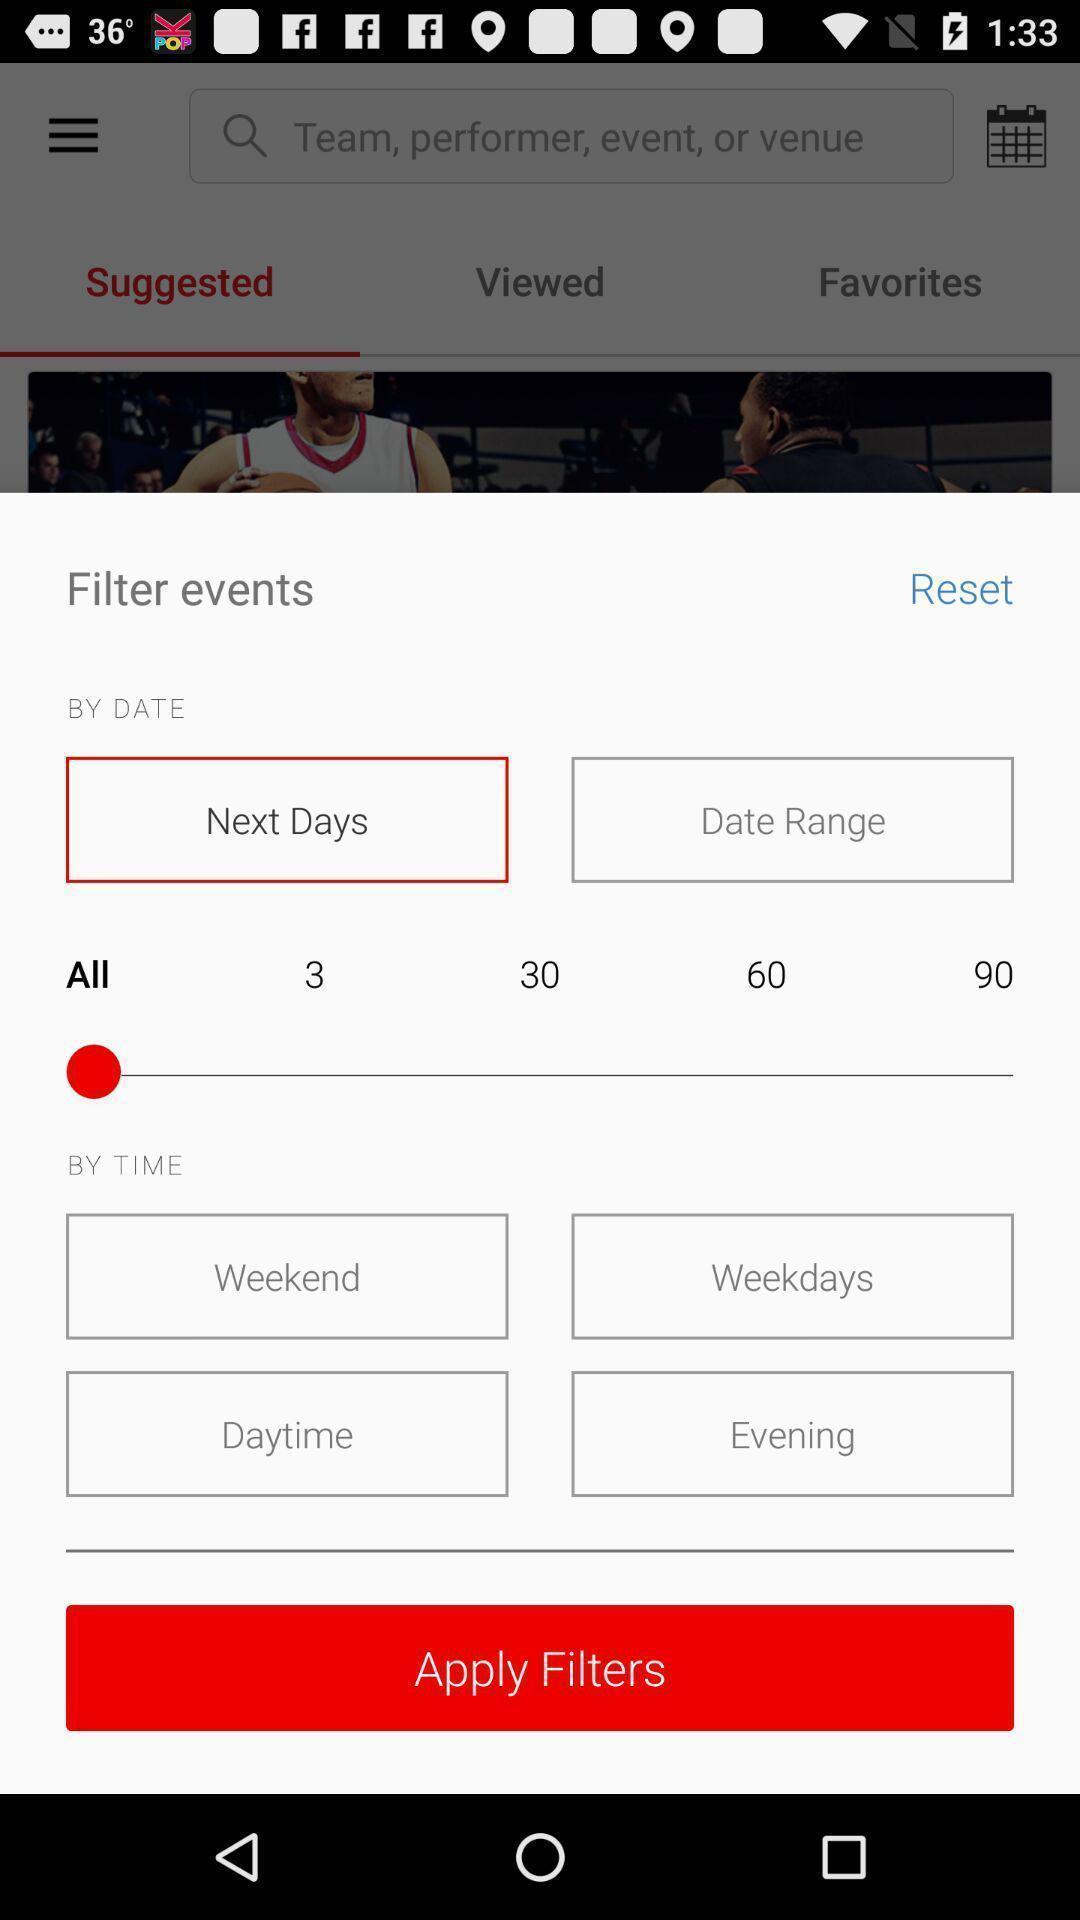Please provide a description for this image. Pop up to apply filters in app. 